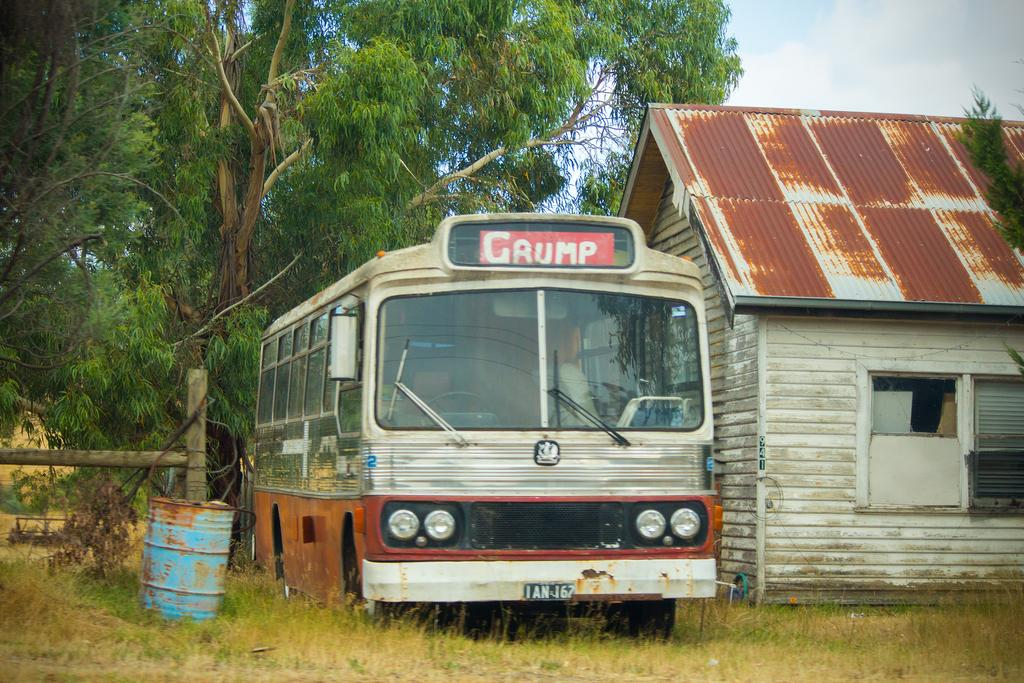<image>
Share a concise interpretation of the image provided. a trailer parked beside a trusted house with a sign of grump on the trailer 